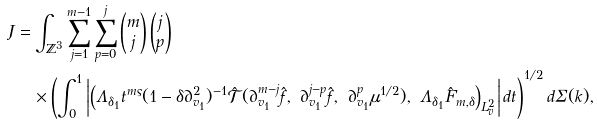<formula> <loc_0><loc_0><loc_500><loc_500>J & = \int _ { \mathbb { Z } ^ { 3 } } \sum _ { j = 1 } ^ { m - 1 } \sum _ { p = 0 } ^ { j } \begin{pmatrix} m \\ j \end{pmatrix} \begin{pmatrix} j \\ p \end{pmatrix} \\ & \quad \times \left ( \int _ { 0 } ^ { 1 } \left | \left ( \Lambda _ { \delta _ { 1 } } t ^ { m \varsigma } ( 1 - \delta \partial _ { v _ { 1 } } ^ { 2 } ) ^ { - 1 } \hat { \mathcal { T } } ( \partial _ { v _ { 1 } } ^ { m - j } \hat { f } , \ \partial _ { v _ { 1 } } ^ { j - p } \hat { f } , \ \partial _ { v _ { 1 } } ^ { p } \mu ^ { 1 / 2 } ) , \ \Lambda _ { \delta _ { 1 } } \hat { F } _ { m , \delta } \right ) _ { L ^ { 2 } _ { v } } \right | d t \right ) ^ { 1 / 2 } d \Sigma ( k ) ,</formula> 